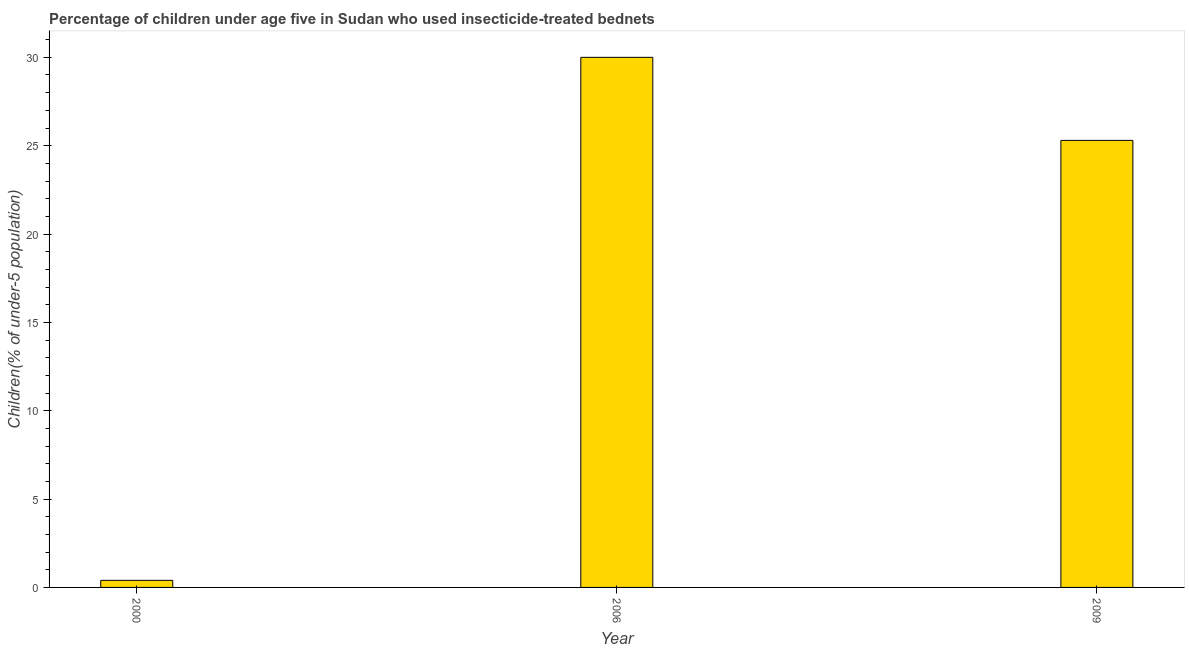Does the graph contain any zero values?
Offer a very short reply. No. Does the graph contain grids?
Provide a succinct answer. No. What is the title of the graph?
Your answer should be very brief. Percentage of children under age five in Sudan who used insecticide-treated bednets. What is the label or title of the X-axis?
Keep it short and to the point. Year. What is the label or title of the Y-axis?
Your answer should be very brief. Children(% of under-5 population). Across all years, what is the maximum percentage of children who use of insecticide-treated bed nets?
Give a very brief answer. 30. Across all years, what is the minimum percentage of children who use of insecticide-treated bed nets?
Give a very brief answer. 0.4. In which year was the percentage of children who use of insecticide-treated bed nets maximum?
Offer a terse response. 2006. What is the sum of the percentage of children who use of insecticide-treated bed nets?
Your answer should be compact. 55.7. What is the difference between the percentage of children who use of insecticide-treated bed nets in 2000 and 2009?
Your answer should be very brief. -24.9. What is the average percentage of children who use of insecticide-treated bed nets per year?
Offer a terse response. 18.57. What is the median percentage of children who use of insecticide-treated bed nets?
Your response must be concise. 25.3. In how many years, is the percentage of children who use of insecticide-treated bed nets greater than 20 %?
Ensure brevity in your answer.  2. What is the ratio of the percentage of children who use of insecticide-treated bed nets in 2000 to that in 2006?
Offer a very short reply. 0.01. Is the percentage of children who use of insecticide-treated bed nets in 2006 less than that in 2009?
Your answer should be very brief. No. Is the difference between the percentage of children who use of insecticide-treated bed nets in 2000 and 2006 greater than the difference between any two years?
Make the answer very short. Yes. What is the difference between the highest and the lowest percentage of children who use of insecticide-treated bed nets?
Provide a short and direct response. 29.6. How many years are there in the graph?
Offer a very short reply. 3. Are the values on the major ticks of Y-axis written in scientific E-notation?
Your response must be concise. No. What is the Children(% of under-5 population) of 2000?
Make the answer very short. 0.4. What is the Children(% of under-5 population) in 2009?
Give a very brief answer. 25.3. What is the difference between the Children(% of under-5 population) in 2000 and 2006?
Keep it short and to the point. -29.6. What is the difference between the Children(% of under-5 population) in 2000 and 2009?
Offer a terse response. -24.9. What is the difference between the Children(% of under-5 population) in 2006 and 2009?
Your answer should be very brief. 4.7. What is the ratio of the Children(% of under-5 population) in 2000 to that in 2006?
Provide a succinct answer. 0.01. What is the ratio of the Children(% of under-5 population) in 2000 to that in 2009?
Ensure brevity in your answer.  0.02. What is the ratio of the Children(% of under-5 population) in 2006 to that in 2009?
Provide a short and direct response. 1.19. 